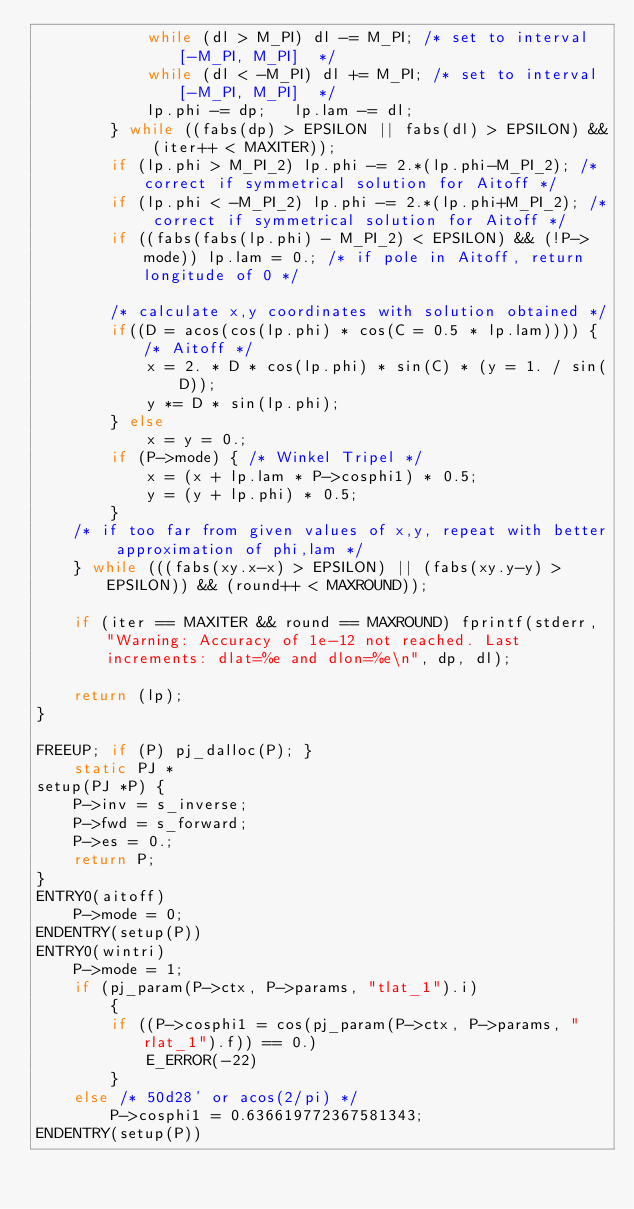Convert code to text. <code><loc_0><loc_0><loc_500><loc_500><_C_>			while (dl > M_PI) dl -= M_PI; /* set to interval [-M_PI, M_PI]  */
			while (dl < -M_PI) dl += M_PI; /* set to interval [-M_PI, M_PI]  */
			lp.phi -= dp;	lp.lam -= dl;
		} while ((fabs(dp) > EPSILON || fabs(dl) > EPSILON) && (iter++ < MAXITER));
		if (lp.phi > M_PI_2) lp.phi -= 2.*(lp.phi-M_PI_2); /* correct if symmetrical solution for Aitoff */ 
		if (lp.phi < -M_PI_2) lp.phi -= 2.*(lp.phi+M_PI_2); /* correct if symmetrical solution for Aitoff */ 
		if ((fabs(fabs(lp.phi) - M_PI_2) < EPSILON) && (!P->mode)) lp.lam = 0.; /* if pole in Aitoff, return longitude of 0 */ 

		/* calculate x,y coordinates with solution obtained */
		if((D = acos(cos(lp.phi) * cos(C = 0.5 * lp.lam)))) {/* Aitoff */
			x = 2. * D * cos(lp.phi) * sin(C) * (y = 1. / sin(D));
			y *= D * sin(lp.phi);
		} else
			x = y = 0.;
		if (P->mode) { /* Winkel Tripel */
			x = (x + lp.lam * P->cosphi1) * 0.5;
			y = (y + lp.phi) * 0.5;
		}
	/* if too far from given values of x,y, repeat with better approximation of phi,lam */
	} while (((fabs(xy.x-x) > EPSILON) || (fabs(xy.y-y) > EPSILON)) && (round++ < MAXROUND));

	if (iter == MAXITER && round == MAXROUND) fprintf(stderr, "Warning: Accuracy of 1e-12 not reached. Last increments: dlat=%e and dlon=%e\n", dp, dl);

	return (lp);
}

FREEUP; if (P) pj_dalloc(P); }
	static PJ *
setup(PJ *P) {
	P->inv = s_inverse;
	P->fwd = s_forward;
	P->es = 0.;
	return P;
}
ENTRY0(aitoff)
	P->mode = 0;
ENDENTRY(setup(P))
ENTRY0(wintri)
	P->mode = 1;
	if (pj_param(P->ctx, P->params, "tlat_1").i)
        {
		if ((P->cosphi1 = cos(pj_param(P->ctx, P->params, "rlat_1").f)) == 0.)
			E_ERROR(-22)
        }
	else /* 50d28' or acos(2/pi) */
		P->cosphi1 = 0.636619772367581343;
ENDENTRY(setup(P))
</code> 